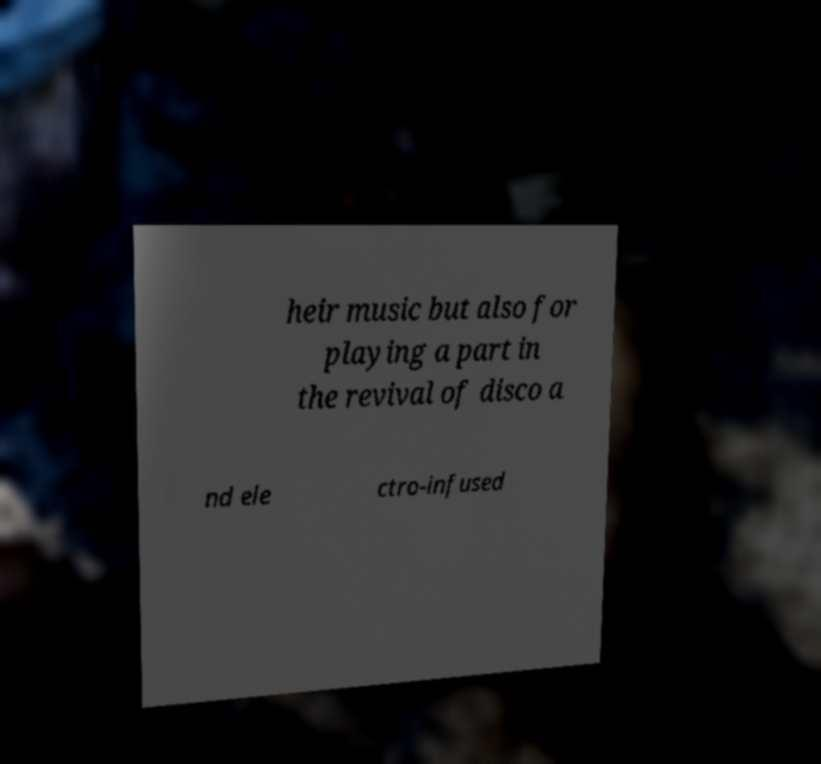Please read and relay the text visible in this image. What does it say? heir music but also for playing a part in the revival of disco a nd ele ctro-infused 